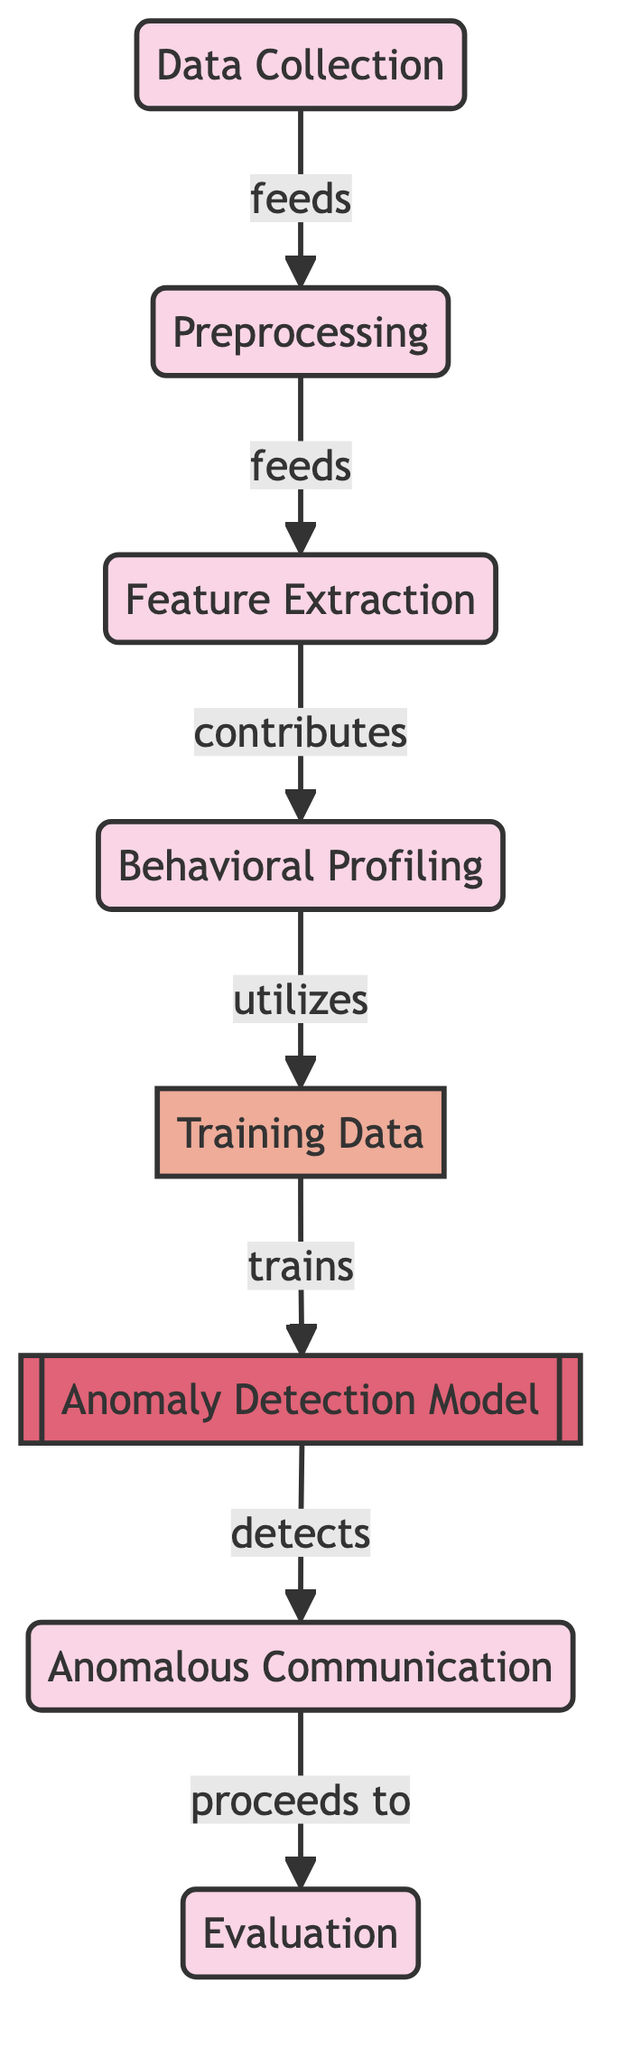What is the first process in the diagram? The first process in the diagram is labeled as "Data Collection," which is the initial step in the anomaly detection workflow.
Answer: Data Collection How many processes are present in the diagram? By counting the nodes labeled as processes, we find there are a total of five processes depicted in the diagram: Data Collection, Preprocessing, Feature Extraction, Behavioral Profiling, and Anomalous Communication.
Answer: Five What role does the "Behavioral Profiling" step have in the process? "Behavioral Profiling" contributes to the "Training Data," indicating it extracts relevant features that help to train the anomaly detection model.
Answer: Contributes What feeds directly into "Preprocessing"? The node "Data Collection" is indicated to feed directly into "Preprocessing," showing the flow of the process.
Answer: Data Collection Which node is trained by the "Training Data"? The node that is trained by the "Training Data" is the "Anomaly Detection Model," which uses this data to learn and identify anomalies.
Answer: Anomaly Detection Model What is the next step after detecting anomalous communication? Once anomalous communication is detected, the next step in the workflow is "Evaluation," where the effectiveness of the detection is assessed.
Answer: Evaluation How many edges are visible in the diagram? The diagram shows a total of six edges that represent the connections between nodes, indicating the flow and relationships between the steps.
Answer: Six What type of model is used in this diagram? The model used in this diagram is specifically labeled as an "Anomaly Detection Model," indicating its purpose in identifying unusual communication patterns.
Answer: Anomaly Detection Model Which step utilizes the "Training Data"? The step that utilizes the "Training Data" is "Behavioral Profiling," indicating that this step analyzes the data for training purposes.
Answer: Behavioral Profiling 